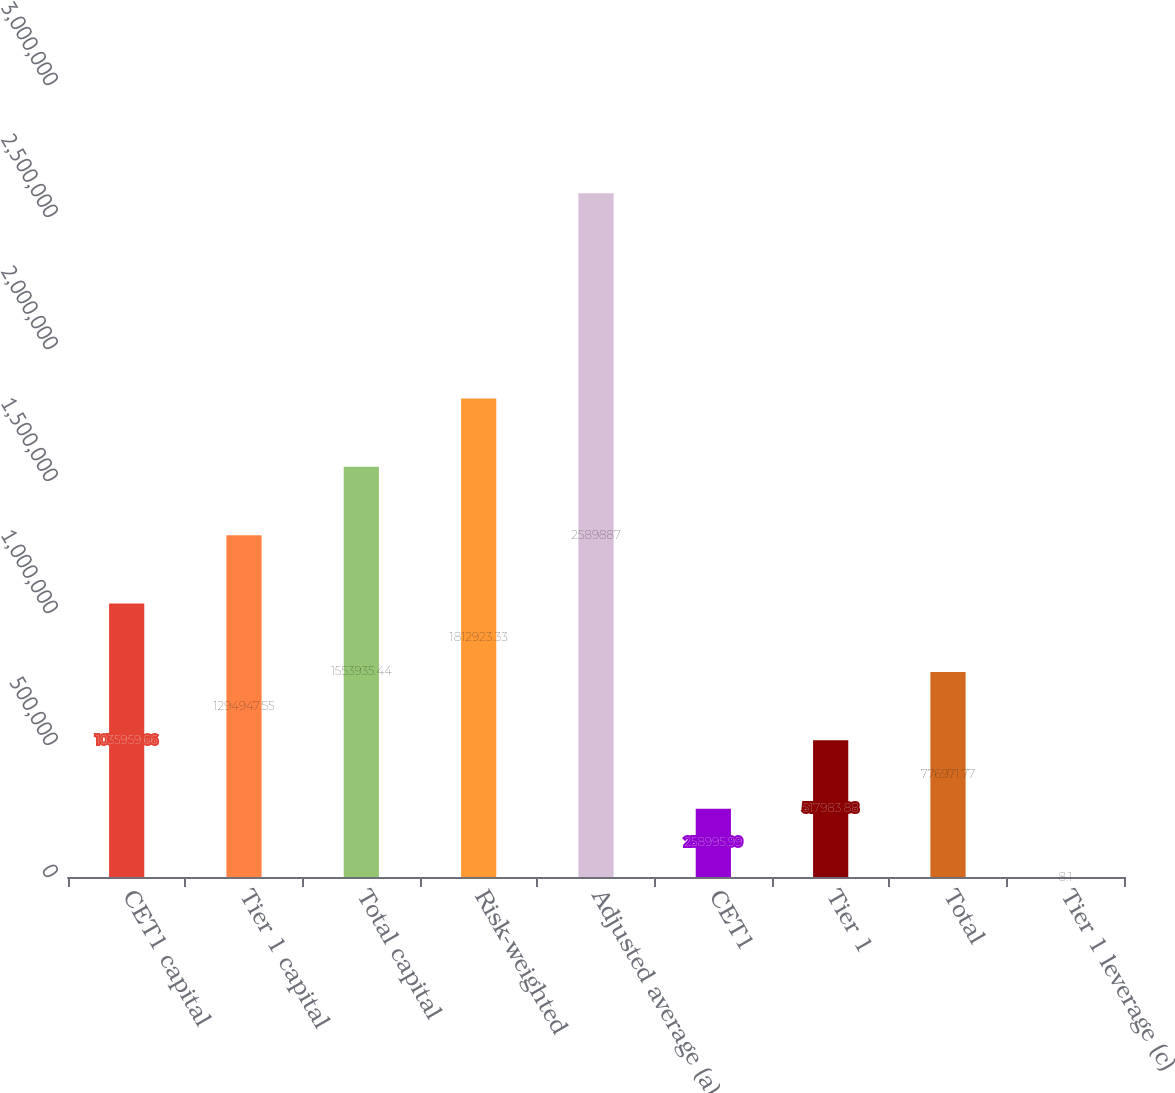<chart> <loc_0><loc_0><loc_500><loc_500><bar_chart><fcel>CET1 capital<fcel>Tier 1 capital<fcel>Total capital<fcel>Risk-weighted<fcel>Adjusted average (a)<fcel>CET1<fcel>Tier 1<fcel>Total<fcel>Tier 1 leverage (c)<nl><fcel>1.03596e+06<fcel>1.29495e+06<fcel>1.55394e+06<fcel>1.81292e+06<fcel>2.58989e+06<fcel>258996<fcel>517984<fcel>776972<fcel>8.1<nl></chart> 